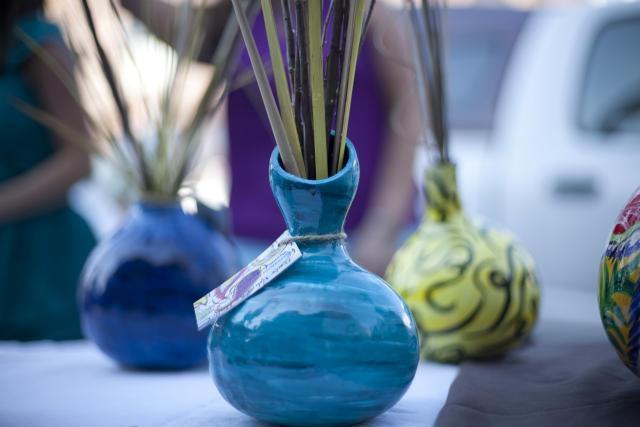How many vases?
Give a very brief answer. 4. How many potted plants are there?
Give a very brief answer. 3. How many vases are there?
Give a very brief answer. 4. How many birds are in the air flying?
Give a very brief answer. 0. 